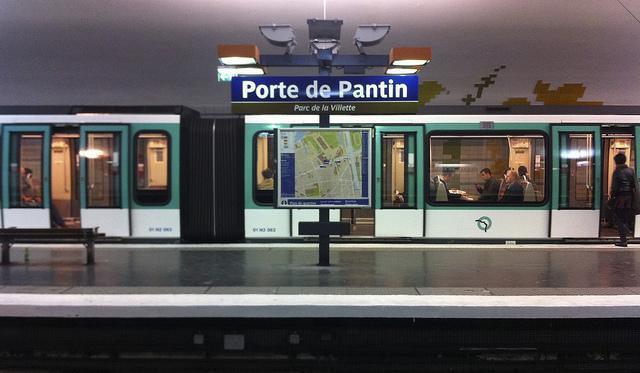How many trains are visible?
Give a very brief answer. 1. 